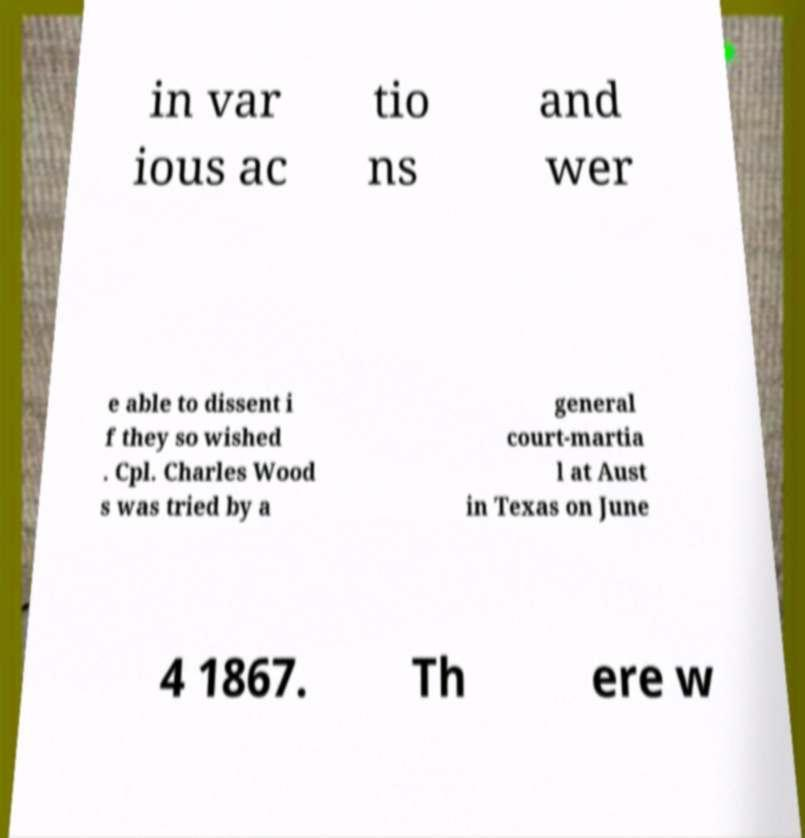Please identify and transcribe the text found in this image. in var ious ac tio ns and wer e able to dissent i f they so wished . Cpl. Charles Wood s was tried by a general court-martia l at Aust in Texas on June 4 1867. Th ere w 